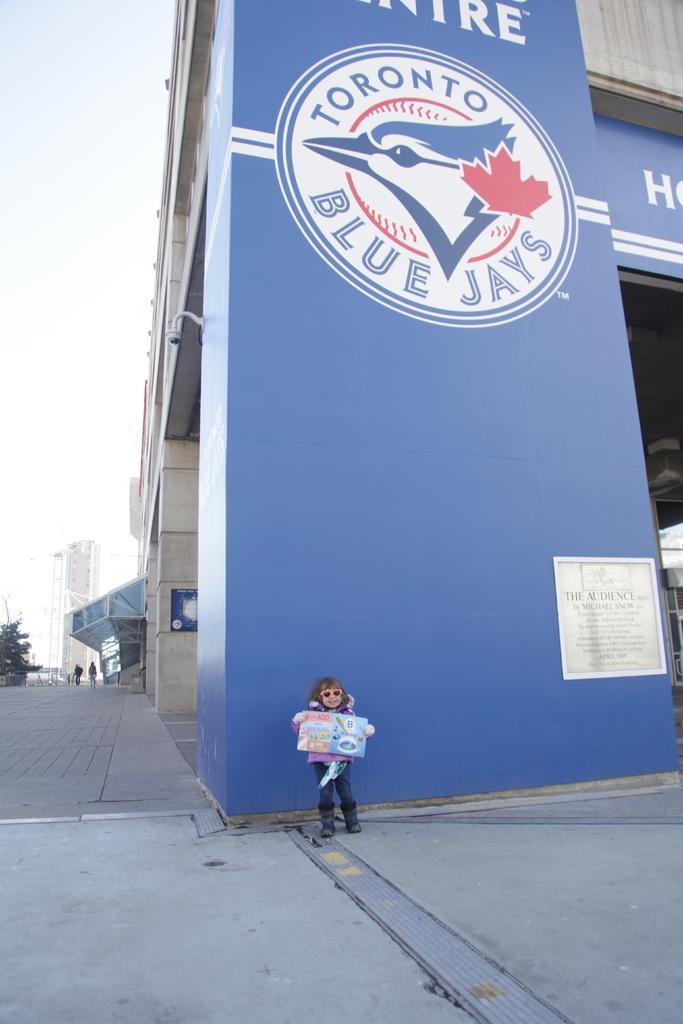Describe this image in one or two sentences. The picture is taken outside the city. In the foreground of the picture there is a kid on the pavement. In the background to the left there are trees, people and buildings. In the foreground of the picture there is a building. Sky is cloudy. 